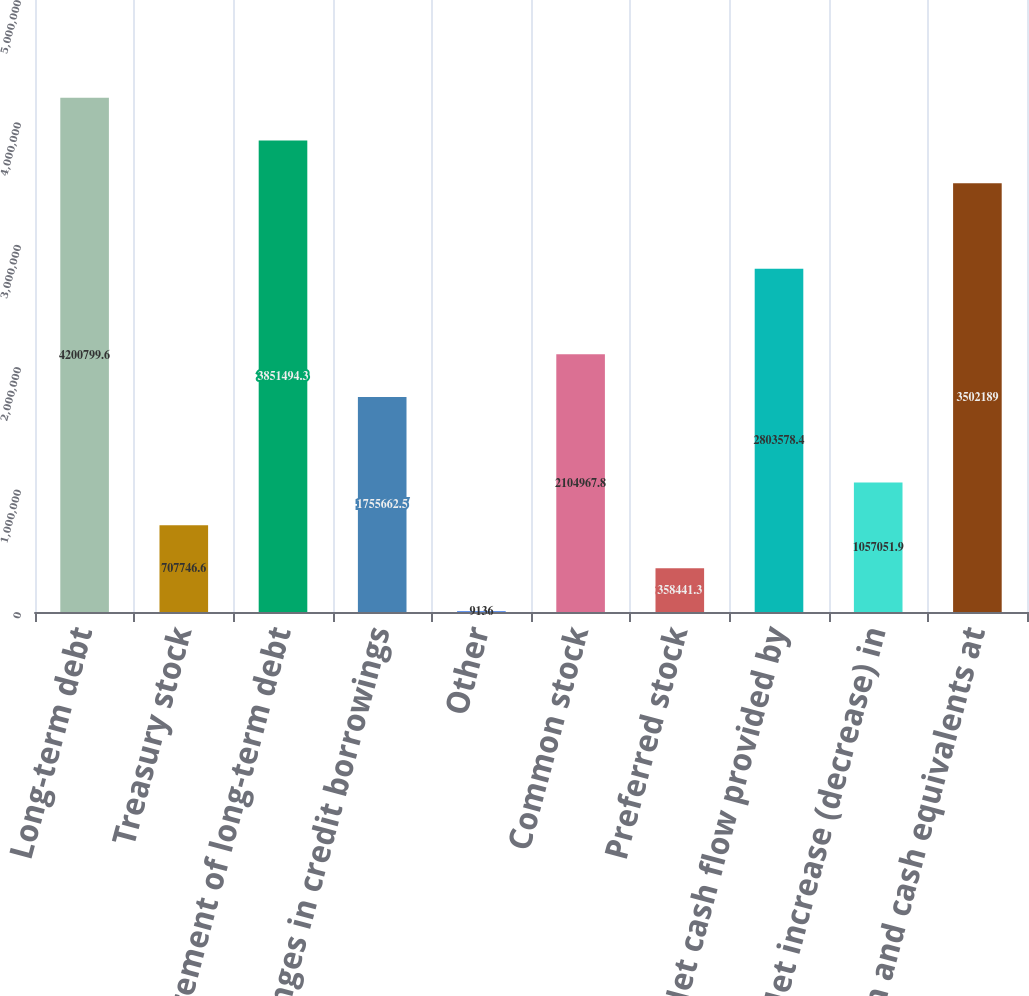Convert chart to OTSL. <chart><loc_0><loc_0><loc_500><loc_500><bar_chart><fcel>Long-term debt<fcel>Treasury stock<fcel>Retirement of long-term debt<fcel>Changes in credit borrowings<fcel>Other<fcel>Common stock<fcel>Preferred stock<fcel>Net cash flow provided by<fcel>Net increase (decrease) in<fcel>Cash and cash equivalents at<nl><fcel>4.2008e+06<fcel>707747<fcel>3.85149e+06<fcel>1.75566e+06<fcel>9136<fcel>2.10497e+06<fcel>358441<fcel>2.80358e+06<fcel>1.05705e+06<fcel>3.50219e+06<nl></chart> 